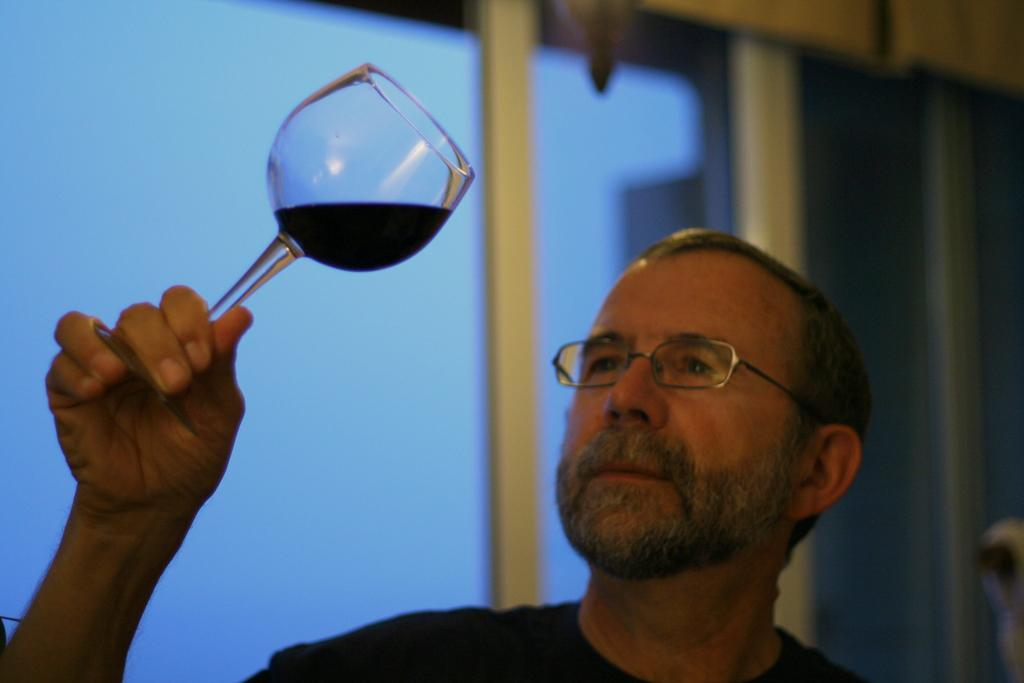What is the person holding in the image? The person is holding a glass with a drink. Can you describe any accessories the person is wearing? The person is wearing glasses. What type of architectural feature can be seen in the background of the image? There is a glass window in the background of the image. What color is the person's body in the image? The image does not show the person's body, only their face and the glass they are holding. Where is the recess located in the image? There is no recess present in the image. 